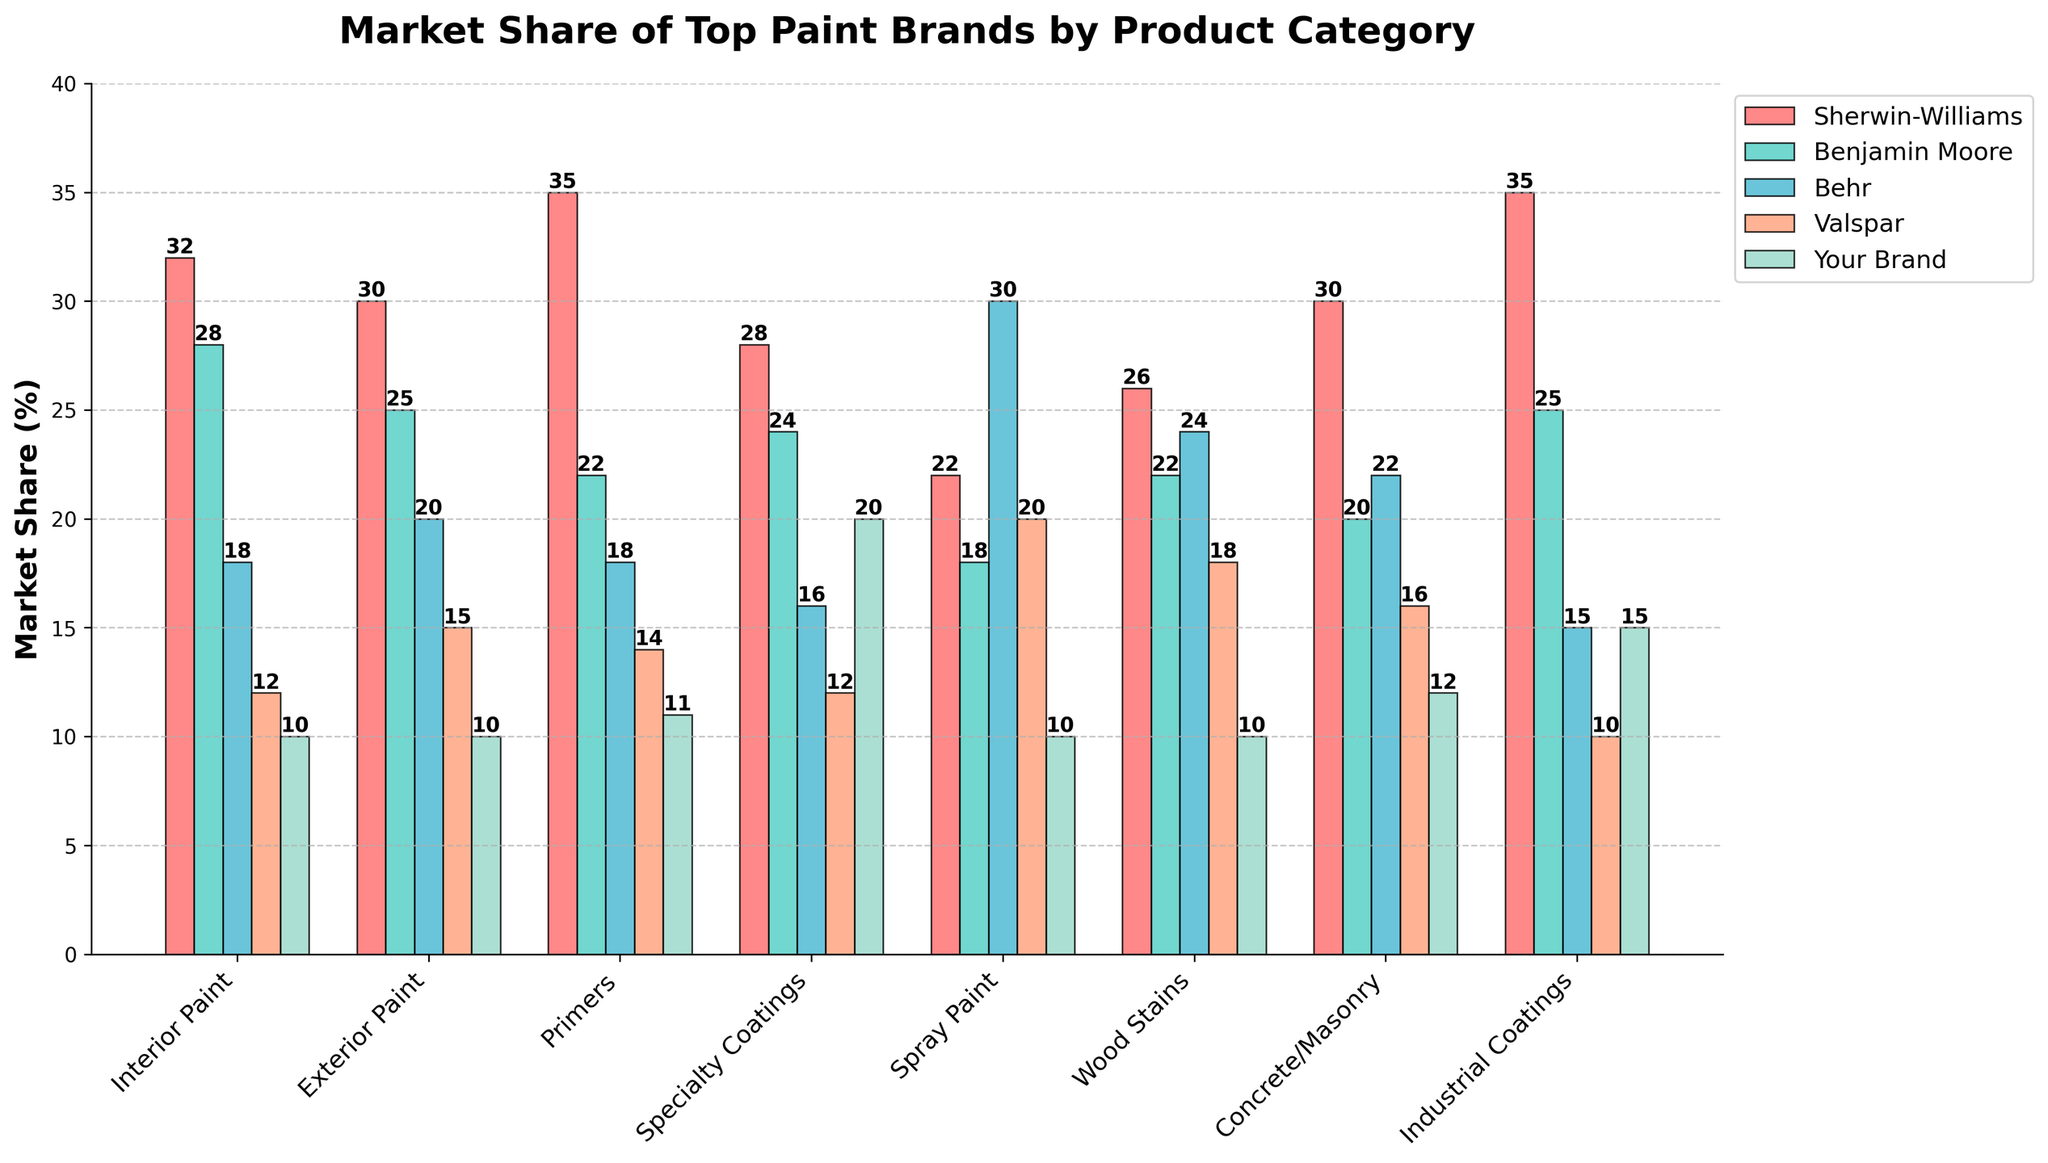Which paint brand leads the market share in the Interior Paint category? The bar for Sherwin-Williams in the Interior Paint category is the highest, indicating they have the largest market share.
Answer: Sherwin-Williams Between Your Brand and Behr, which brand has a higher market share in the Specialty Coatings category and by how much? Behr has a 16% market share, while Your Brand has a 20% market share in Specialty Coatings. The difference is 20% - 16% = 4%.
Answer: Your Brand by 4% What is the combined market share percentage of Sherwin-Williams and Benjamin Moore for Primers? Summing up the percentages for Sherwin-Williams (35%) and Benjamin Moore (22%) in Primers gives 35% + 22% = 57%.
Answer: 57% Which product category shows the highest market share for Behr? The bar representing Behr's market share in Spray Paint is the highest at 30%.
Answer: Spray Paint Is Your Brand's market share in Wood Stains greater than or equal to its share in Concrete/Masonry? Comparing the heights of the bars for Your Brand in Wood Stains (10%) and Concrete/Masonry (12%), the bar for Concrete/Masonry is slightly higher.
Answer: No How does Your Brand's market share in Interior Paint compare to Valspar's market share in the same category? For the Interior Paint category, Your Brand has a 10% market share, while Valspar has a 12% market share.
Answer: Valspar has a higher market share What is the average market share of Your Brand across all categories? Summing Your Brand's market shares (10% + 10% + 11% + 20% + 10% + 10% + 12% + 15%) and dividing by the number of categories (8) gives (98%/8) = 12.25%.
Answer: 12.25% In which category does Sherwin-Williams have the second-highest market share and what is the percentage? Sherwin-Williams' second-highest market share is in Industrial Coatings at 35%. The highest is in Primers.
Answer: Industrial Coatings, 35% Which two brands have equal market share in any product category, and what is the category? Both Sherwin-Williams and Benjamin Moore have a market share of 25% each in Exterior Paint.
Answer: Sherwin-Williams and Benjamin Moore, Exterior Paint What's the visual difference between the market shares of Sherwin-Williams and Behr in the Interior Paint category? The bar for Sherwin-Williams (32%) is significantly higher than Behr (18%) in the Interior Paint category, indicating a 14% difference.
Answer: 14% 